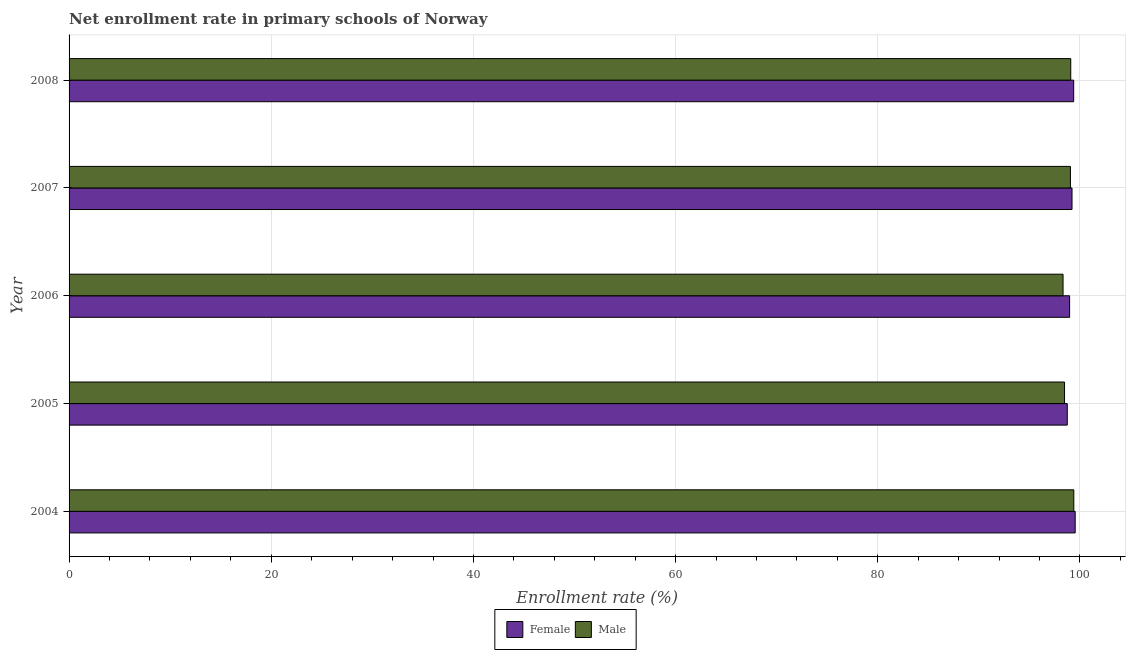How many different coloured bars are there?
Keep it short and to the point. 2. Are the number of bars per tick equal to the number of legend labels?
Provide a succinct answer. Yes. How many bars are there on the 1st tick from the bottom?
Your answer should be very brief. 2. What is the label of the 4th group of bars from the top?
Provide a short and direct response. 2005. What is the enrollment rate of female students in 2005?
Provide a short and direct response. 98.74. Across all years, what is the maximum enrollment rate of male students?
Offer a very short reply. 99.39. Across all years, what is the minimum enrollment rate of male students?
Your answer should be very brief. 98.32. In which year was the enrollment rate of female students maximum?
Offer a very short reply. 2004. In which year was the enrollment rate of male students minimum?
Your answer should be very brief. 2006. What is the total enrollment rate of male students in the graph?
Offer a very short reply. 494.32. What is the difference between the enrollment rate of female students in 2005 and that in 2007?
Offer a very short reply. -0.47. What is the difference between the enrollment rate of male students in 2008 and the enrollment rate of female students in 2004?
Your answer should be very brief. -0.44. What is the average enrollment rate of female students per year?
Your answer should be very brief. 99.17. In the year 2004, what is the difference between the enrollment rate of female students and enrollment rate of male students?
Keep it short and to the point. 0.14. In how many years, is the enrollment rate of female students greater than 16 %?
Make the answer very short. 5. What is the ratio of the enrollment rate of male students in 2005 to that in 2007?
Offer a very short reply. 0.99. What is the difference between the highest and the second highest enrollment rate of female students?
Your response must be concise. 0.15. What is the difference between the highest and the lowest enrollment rate of male students?
Your answer should be very brief. 1.06. Is the sum of the enrollment rate of female students in 2005 and 2008 greater than the maximum enrollment rate of male students across all years?
Ensure brevity in your answer.  Yes. Are all the bars in the graph horizontal?
Your answer should be very brief. Yes. How many years are there in the graph?
Offer a very short reply. 5. What is the difference between two consecutive major ticks on the X-axis?
Your answer should be compact. 20. Are the values on the major ticks of X-axis written in scientific E-notation?
Ensure brevity in your answer.  No. Does the graph contain grids?
Keep it short and to the point. Yes. How many legend labels are there?
Offer a very short reply. 2. How are the legend labels stacked?
Provide a succinct answer. Horizontal. What is the title of the graph?
Your response must be concise. Net enrollment rate in primary schools of Norway. Does "Study and work" appear as one of the legend labels in the graph?
Keep it short and to the point. No. What is the label or title of the X-axis?
Offer a very short reply. Enrollment rate (%). What is the label or title of the Y-axis?
Offer a terse response. Year. What is the Enrollment rate (%) of Female in 2004?
Keep it short and to the point. 99.52. What is the Enrollment rate (%) of Male in 2004?
Offer a very short reply. 99.39. What is the Enrollment rate (%) in Female in 2005?
Offer a terse response. 98.74. What is the Enrollment rate (%) in Male in 2005?
Offer a very short reply. 98.47. What is the Enrollment rate (%) of Female in 2006?
Your response must be concise. 98.97. What is the Enrollment rate (%) of Male in 2006?
Make the answer very short. 98.32. What is the Enrollment rate (%) of Female in 2007?
Your response must be concise. 99.21. What is the Enrollment rate (%) in Male in 2007?
Your response must be concise. 99.05. What is the Enrollment rate (%) in Female in 2008?
Keep it short and to the point. 99.38. What is the Enrollment rate (%) in Male in 2008?
Keep it short and to the point. 99.09. Across all years, what is the maximum Enrollment rate (%) in Female?
Ensure brevity in your answer.  99.52. Across all years, what is the maximum Enrollment rate (%) in Male?
Give a very brief answer. 99.39. Across all years, what is the minimum Enrollment rate (%) in Female?
Provide a succinct answer. 98.74. Across all years, what is the minimum Enrollment rate (%) of Male?
Ensure brevity in your answer.  98.32. What is the total Enrollment rate (%) of Female in the graph?
Ensure brevity in your answer.  495.83. What is the total Enrollment rate (%) in Male in the graph?
Offer a terse response. 494.32. What is the difference between the Enrollment rate (%) in Female in 2004 and that in 2005?
Keep it short and to the point. 0.78. What is the difference between the Enrollment rate (%) in Male in 2004 and that in 2005?
Offer a terse response. 0.92. What is the difference between the Enrollment rate (%) in Female in 2004 and that in 2006?
Ensure brevity in your answer.  0.55. What is the difference between the Enrollment rate (%) of Male in 2004 and that in 2006?
Your response must be concise. 1.06. What is the difference between the Enrollment rate (%) of Female in 2004 and that in 2007?
Your response must be concise. 0.31. What is the difference between the Enrollment rate (%) in Male in 2004 and that in 2007?
Offer a terse response. 0.34. What is the difference between the Enrollment rate (%) in Female in 2004 and that in 2008?
Give a very brief answer. 0.15. What is the difference between the Enrollment rate (%) of Male in 2004 and that in 2008?
Provide a short and direct response. 0.3. What is the difference between the Enrollment rate (%) of Female in 2005 and that in 2006?
Ensure brevity in your answer.  -0.23. What is the difference between the Enrollment rate (%) of Male in 2005 and that in 2006?
Your response must be concise. 0.15. What is the difference between the Enrollment rate (%) in Female in 2005 and that in 2007?
Offer a terse response. -0.47. What is the difference between the Enrollment rate (%) of Male in 2005 and that in 2007?
Make the answer very short. -0.58. What is the difference between the Enrollment rate (%) of Female in 2005 and that in 2008?
Ensure brevity in your answer.  -0.64. What is the difference between the Enrollment rate (%) in Male in 2005 and that in 2008?
Make the answer very short. -0.61. What is the difference between the Enrollment rate (%) in Female in 2006 and that in 2007?
Ensure brevity in your answer.  -0.24. What is the difference between the Enrollment rate (%) in Male in 2006 and that in 2007?
Give a very brief answer. -0.73. What is the difference between the Enrollment rate (%) of Female in 2006 and that in 2008?
Your answer should be compact. -0.4. What is the difference between the Enrollment rate (%) of Male in 2006 and that in 2008?
Your answer should be very brief. -0.76. What is the difference between the Enrollment rate (%) in Female in 2007 and that in 2008?
Offer a terse response. -0.17. What is the difference between the Enrollment rate (%) in Male in 2007 and that in 2008?
Make the answer very short. -0.03. What is the difference between the Enrollment rate (%) in Female in 2004 and the Enrollment rate (%) in Male in 2005?
Keep it short and to the point. 1.05. What is the difference between the Enrollment rate (%) of Female in 2004 and the Enrollment rate (%) of Male in 2006?
Ensure brevity in your answer.  1.2. What is the difference between the Enrollment rate (%) in Female in 2004 and the Enrollment rate (%) in Male in 2007?
Your response must be concise. 0.47. What is the difference between the Enrollment rate (%) of Female in 2004 and the Enrollment rate (%) of Male in 2008?
Offer a very short reply. 0.44. What is the difference between the Enrollment rate (%) in Female in 2005 and the Enrollment rate (%) in Male in 2006?
Your answer should be very brief. 0.42. What is the difference between the Enrollment rate (%) in Female in 2005 and the Enrollment rate (%) in Male in 2007?
Offer a terse response. -0.31. What is the difference between the Enrollment rate (%) in Female in 2005 and the Enrollment rate (%) in Male in 2008?
Offer a very short reply. -0.34. What is the difference between the Enrollment rate (%) of Female in 2006 and the Enrollment rate (%) of Male in 2007?
Offer a very short reply. -0.08. What is the difference between the Enrollment rate (%) of Female in 2006 and the Enrollment rate (%) of Male in 2008?
Your response must be concise. -0.11. What is the difference between the Enrollment rate (%) of Female in 2007 and the Enrollment rate (%) of Male in 2008?
Offer a very short reply. 0.13. What is the average Enrollment rate (%) in Female per year?
Offer a terse response. 99.17. What is the average Enrollment rate (%) of Male per year?
Your answer should be compact. 98.86. In the year 2004, what is the difference between the Enrollment rate (%) of Female and Enrollment rate (%) of Male?
Provide a succinct answer. 0.14. In the year 2005, what is the difference between the Enrollment rate (%) in Female and Enrollment rate (%) in Male?
Offer a very short reply. 0.27. In the year 2006, what is the difference between the Enrollment rate (%) in Female and Enrollment rate (%) in Male?
Provide a succinct answer. 0.65. In the year 2007, what is the difference between the Enrollment rate (%) of Female and Enrollment rate (%) of Male?
Provide a succinct answer. 0.16. In the year 2008, what is the difference between the Enrollment rate (%) in Female and Enrollment rate (%) in Male?
Make the answer very short. 0.29. What is the ratio of the Enrollment rate (%) of Female in 2004 to that in 2005?
Provide a short and direct response. 1.01. What is the ratio of the Enrollment rate (%) in Male in 2004 to that in 2005?
Your response must be concise. 1.01. What is the ratio of the Enrollment rate (%) of Female in 2004 to that in 2006?
Ensure brevity in your answer.  1.01. What is the ratio of the Enrollment rate (%) in Male in 2004 to that in 2006?
Ensure brevity in your answer.  1.01. What is the ratio of the Enrollment rate (%) of Female in 2004 to that in 2007?
Provide a short and direct response. 1. What is the ratio of the Enrollment rate (%) in Male in 2004 to that in 2008?
Ensure brevity in your answer.  1. What is the ratio of the Enrollment rate (%) in Female in 2005 to that in 2006?
Give a very brief answer. 1. What is the ratio of the Enrollment rate (%) of Male in 2005 to that in 2008?
Offer a terse response. 0.99. What is the ratio of the Enrollment rate (%) of Male in 2006 to that in 2007?
Offer a terse response. 0.99. What is the ratio of the Enrollment rate (%) in Female in 2006 to that in 2008?
Make the answer very short. 1. What is the ratio of the Enrollment rate (%) in Female in 2007 to that in 2008?
Keep it short and to the point. 1. What is the ratio of the Enrollment rate (%) in Male in 2007 to that in 2008?
Your answer should be very brief. 1. What is the difference between the highest and the second highest Enrollment rate (%) of Female?
Provide a succinct answer. 0.15. What is the difference between the highest and the second highest Enrollment rate (%) of Male?
Provide a short and direct response. 0.3. What is the difference between the highest and the lowest Enrollment rate (%) in Female?
Make the answer very short. 0.78. What is the difference between the highest and the lowest Enrollment rate (%) of Male?
Provide a succinct answer. 1.06. 